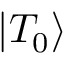<formula> <loc_0><loc_0><loc_500><loc_500>\left | { { T _ { 0 } } } \right \rangle</formula> 